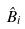Convert formula to latex. <formula><loc_0><loc_0><loc_500><loc_500>\hat { B } _ { i }</formula> 